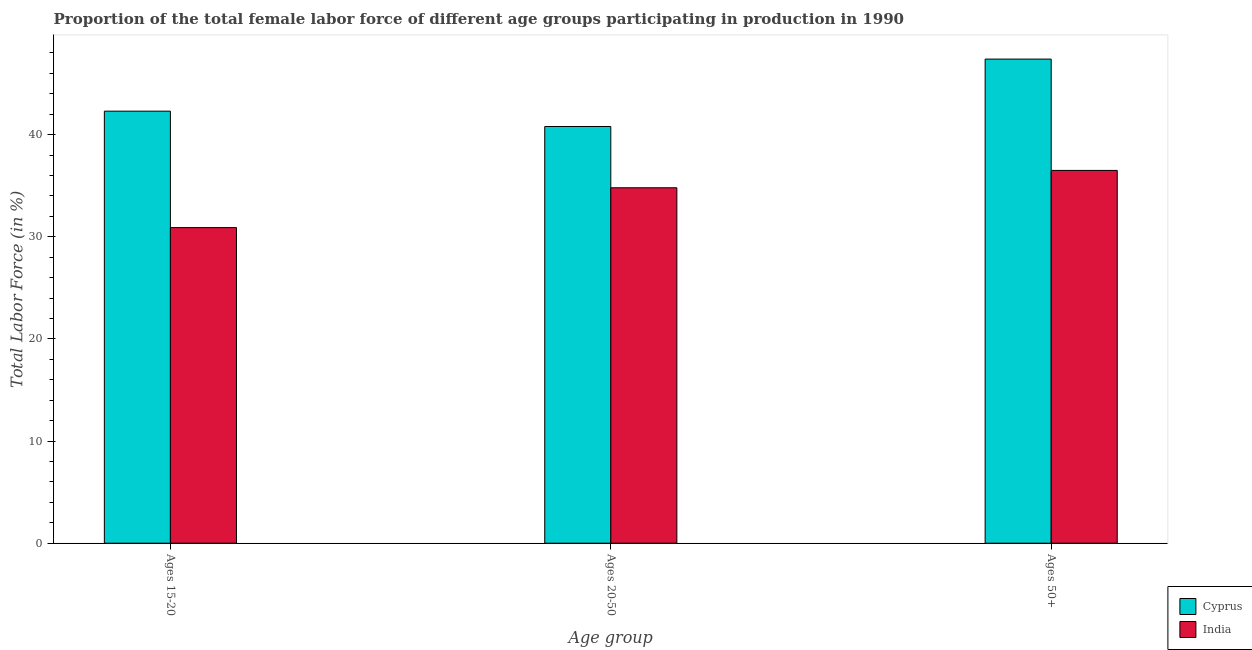How many different coloured bars are there?
Your answer should be compact. 2. How many groups of bars are there?
Ensure brevity in your answer.  3. How many bars are there on the 1st tick from the left?
Provide a succinct answer. 2. How many bars are there on the 3rd tick from the right?
Provide a short and direct response. 2. What is the label of the 3rd group of bars from the left?
Offer a terse response. Ages 50+. What is the percentage of female labor force within the age group 15-20 in India?
Your answer should be very brief. 30.9. Across all countries, what is the maximum percentage of female labor force within the age group 20-50?
Ensure brevity in your answer.  40.8. Across all countries, what is the minimum percentage of female labor force above age 50?
Make the answer very short. 36.5. In which country was the percentage of female labor force above age 50 maximum?
Your response must be concise. Cyprus. In which country was the percentage of female labor force within the age group 20-50 minimum?
Your response must be concise. India. What is the total percentage of female labor force within the age group 15-20 in the graph?
Offer a very short reply. 73.2. What is the difference between the percentage of female labor force within the age group 15-20 in Cyprus and that in India?
Your answer should be very brief. 11.4. What is the difference between the percentage of female labor force above age 50 in India and the percentage of female labor force within the age group 15-20 in Cyprus?
Offer a terse response. -5.8. What is the average percentage of female labor force within the age group 20-50 per country?
Provide a succinct answer. 37.8. What is the difference between the percentage of female labor force within the age group 15-20 and percentage of female labor force above age 50 in India?
Provide a succinct answer. -5.6. In how many countries, is the percentage of female labor force within the age group 15-20 greater than 2 %?
Provide a short and direct response. 2. What is the ratio of the percentage of female labor force within the age group 15-20 in Cyprus to that in India?
Keep it short and to the point. 1.37. What is the difference between the highest and the second highest percentage of female labor force within the age group 15-20?
Provide a short and direct response. 11.4. What is the difference between the highest and the lowest percentage of female labor force above age 50?
Your response must be concise. 10.9. What does the 2nd bar from the left in Ages 50+ represents?
Offer a very short reply. India. What does the 2nd bar from the right in Ages 20-50 represents?
Provide a short and direct response. Cyprus. How many bars are there?
Provide a succinct answer. 6. Are all the bars in the graph horizontal?
Make the answer very short. No. How many countries are there in the graph?
Provide a short and direct response. 2. Are the values on the major ticks of Y-axis written in scientific E-notation?
Your answer should be very brief. No. Does the graph contain any zero values?
Your response must be concise. No. Does the graph contain grids?
Offer a terse response. No. Where does the legend appear in the graph?
Offer a very short reply. Bottom right. How are the legend labels stacked?
Your answer should be compact. Vertical. What is the title of the graph?
Provide a succinct answer. Proportion of the total female labor force of different age groups participating in production in 1990. Does "Pacific island small states" appear as one of the legend labels in the graph?
Provide a short and direct response. No. What is the label or title of the X-axis?
Ensure brevity in your answer.  Age group. What is the Total Labor Force (in %) of Cyprus in Ages 15-20?
Your response must be concise. 42.3. What is the Total Labor Force (in %) in India in Ages 15-20?
Make the answer very short. 30.9. What is the Total Labor Force (in %) in Cyprus in Ages 20-50?
Your answer should be compact. 40.8. What is the Total Labor Force (in %) in India in Ages 20-50?
Offer a terse response. 34.8. What is the Total Labor Force (in %) in Cyprus in Ages 50+?
Provide a short and direct response. 47.4. What is the Total Labor Force (in %) of India in Ages 50+?
Make the answer very short. 36.5. Across all Age group, what is the maximum Total Labor Force (in %) in Cyprus?
Make the answer very short. 47.4. Across all Age group, what is the maximum Total Labor Force (in %) in India?
Your response must be concise. 36.5. Across all Age group, what is the minimum Total Labor Force (in %) of Cyprus?
Your answer should be compact. 40.8. Across all Age group, what is the minimum Total Labor Force (in %) in India?
Ensure brevity in your answer.  30.9. What is the total Total Labor Force (in %) of Cyprus in the graph?
Ensure brevity in your answer.  130.5. What is the total Total Labor Force (in %) in India in the graph?
Offer a terse response. 102.2. What is the difference between the Total Labor Force (in %) in Cyprus in Ages 20-50 and that in Ages 50+?
Your answer should be very brief. -6.6. What is the difference between the Total Labor Force (in %) in India in Ages 20-50 and that in Ages 50+?
Your response must be concise. -1.7. What is the difference between the Total Labor Force (in %) of Cyprus in Ages 15-20 and the Total Labor Force (in %) of India in Ages 20-50?
Provide a succinct answer. 7.5. What is the average Total Labor Force (in %) of Cyprus per Age group?
Provide a short and direct response. 43.5. What is the average Total Labor Force (in %) of India per Age group?
Offer a very short reply. 34.07. What is the difference between the Total Labor Force (in %) in Cyprus and Total Labor Force (in %) in India in Ages 15-20?
Your response must be concise. 11.4. What is the difference between the Total Labor Force (in %) of Cyprus and Total Labor Force (in %) of India in Ages 20-50?
Ensure brevity in your answer.  6. What is the difference between the Total Labor Force (in %) in Cyprus and Total Labor Force (in %) in India in Ages 50+?
Give a very brief answer. 10.9. What is the ratio of the Total Labor Force (in %) in Cyprus in Ages 15-20 to that in Ages 20-50?
Give a very brief answer. 1.04. What is the ratio of the Total Labor Force (in %) of India in Ages 15-20 to that in Ages 20-50?
Keep it short and to the point. 0.89. What is the ratio of the Total Labor Force (in %) in Cyprus in Ages 15-20 to that in Ages 50+?
Your answer should be very brief. 0.89. What is the ratio of the Total Labor Force (in %) in India in Ages 15-20 to that in Ages 50+?
Offer a very short reply. 0.85. What is the ratio of the Total Labor Force (in %) of Cyprus in Ages 20-50 to that in Ages 50+?
Give a very brief answer. 0.86. What is the ratio of the Total Labor Force (in %) in India in Ages 20-50 to that in Ages 50+?
Your response must be concise. 0.95. What is the difference between the highest and the second highest Total Labor Force (in %) of India?
Provide a succinct answer. 1.7. What is the difference between the highest and the lowest Total Labor Force (in %) in Cyprus?
Offer a very short reply. 6.6. 